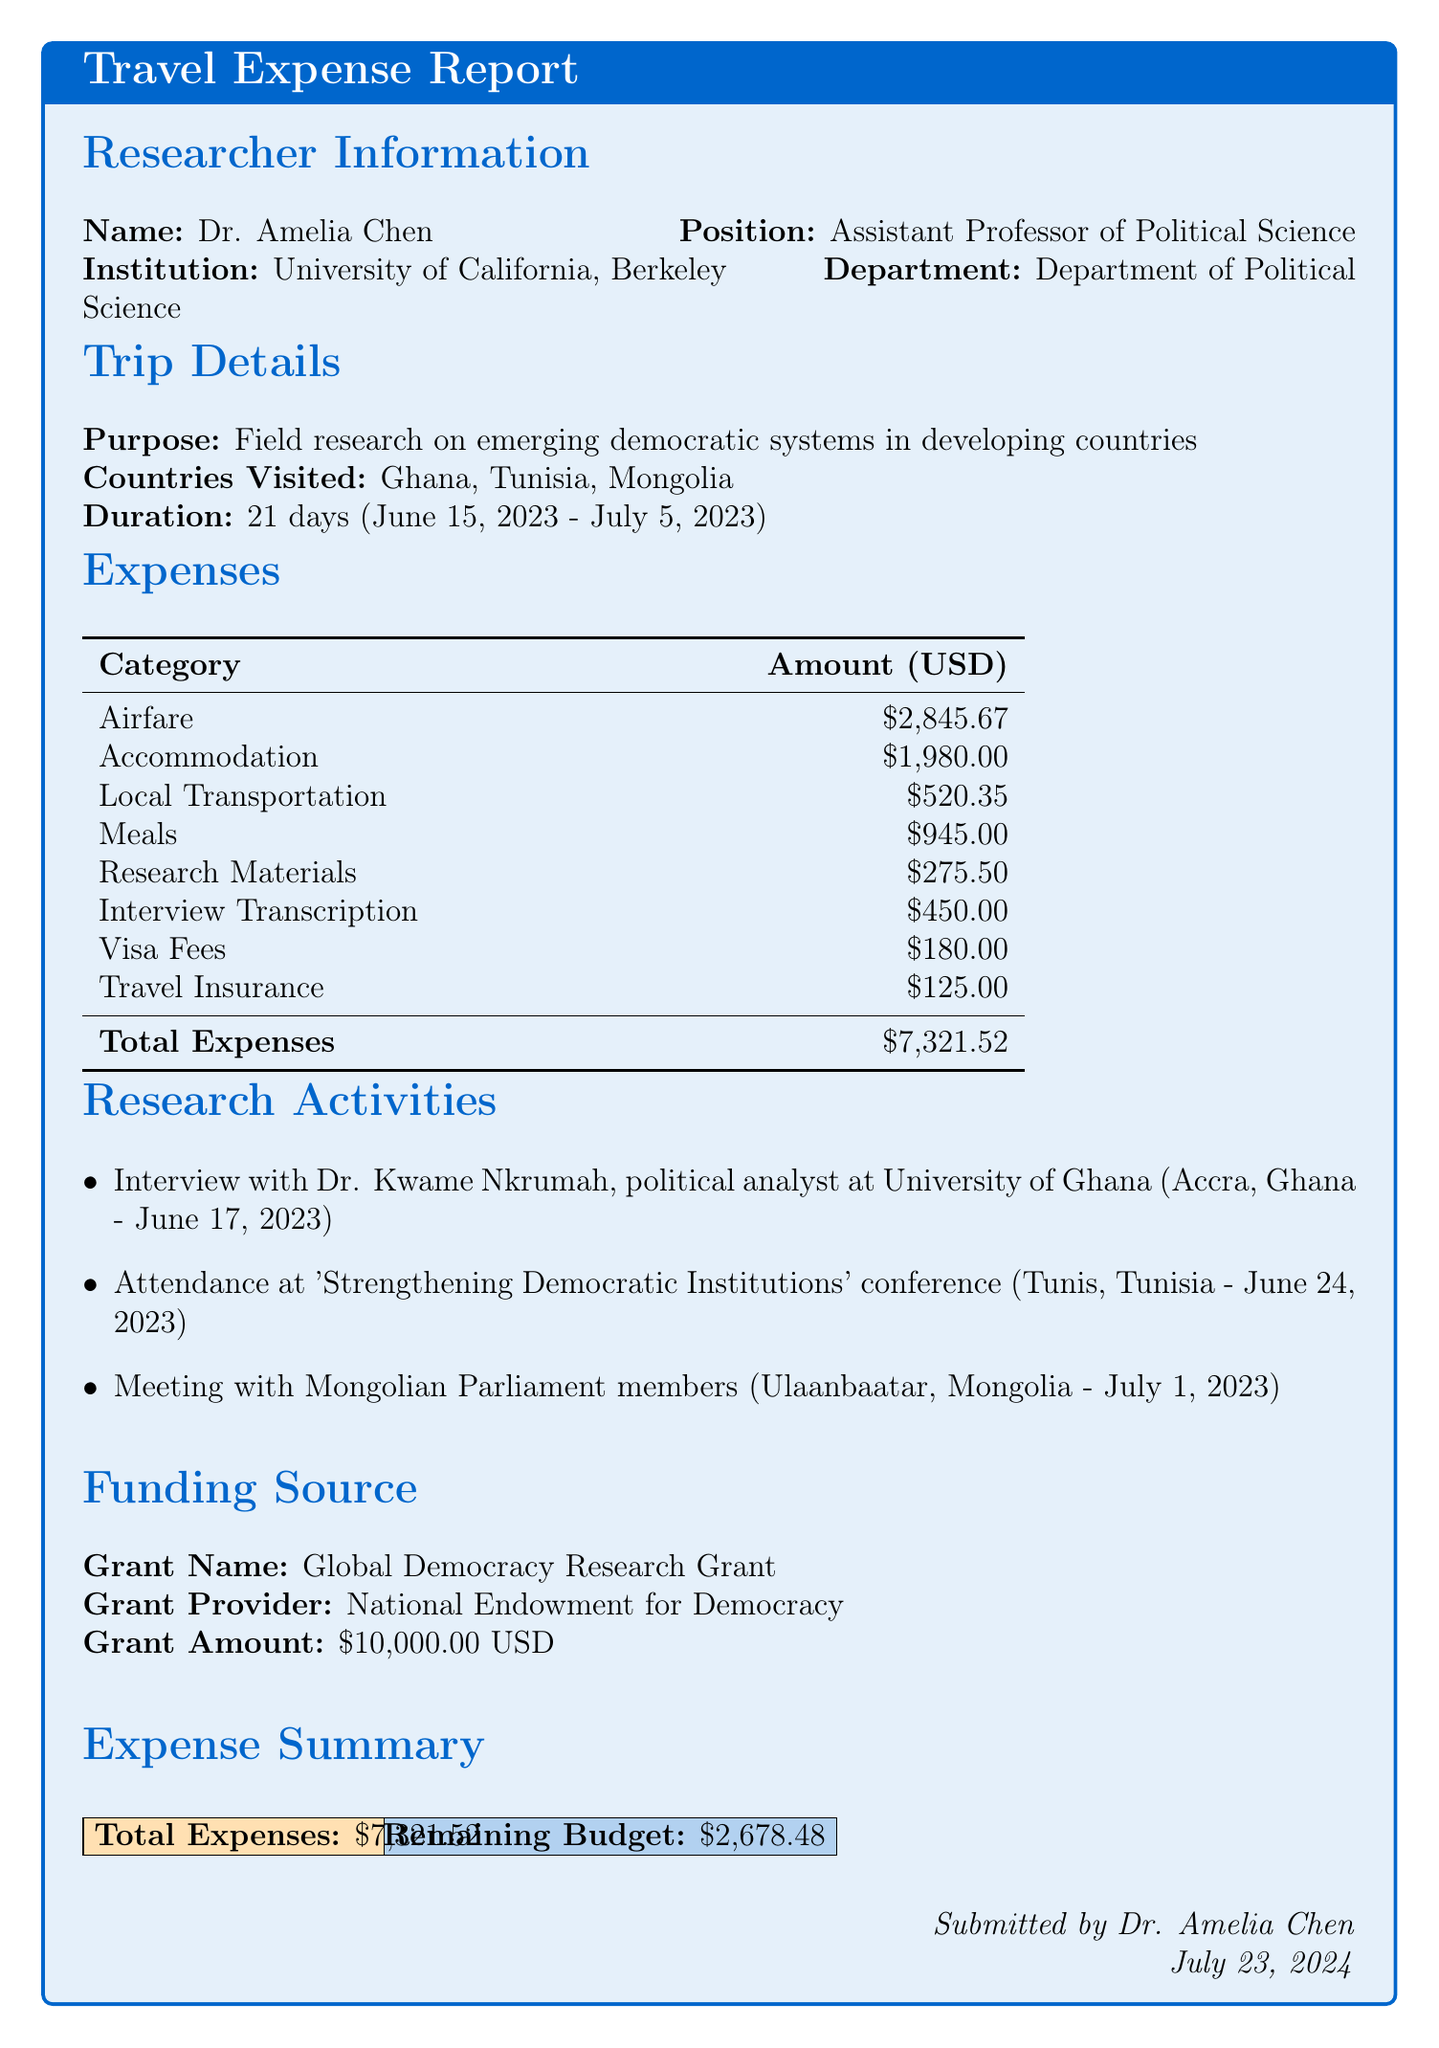What is the name of the researcher? The document provides the name of the researcher, which is Dr. Amelia Chen.
Answer: Dr. Amelia Chen What is the total amount of expenses? The total expenses are listed in the expense summary, which amounts to $7,321.52.
Answer: $7,321.52 How many countries were visited during the trip? The document mentions three countries visited: Ghana, Tunisia, and Mongolia.
Answer: Three What was the purpose of the trip? The purpose of the trip, as stated in the trip details, is field research on emerging democratic systems in developing countries.
Answer: Field research on emerging democratic systems in developing countries How many days did the trip last? The duration of the trip is clearly stated as 21 days.
Answer: 21 days What funding source was used for this research? The funding source listed is the Global Democracy Research Grant.
Answer: Global Democracy Research Grant Which city hosted the conference attended during the trip? The conference was held in Tunis, Tunisia, as noted in the research activities section.
Answer: Tunis When did the research activities take place? The dates of the research activities span from June 17, 2023, to July 1, 2023, as detailed in the research activities section.
Answer: June 17, 2023 - July 1, 2023 What is the remaining budget amount? The remaining budget is stated in the expense summary as $2,678.48.
Answer: $2,678.48 